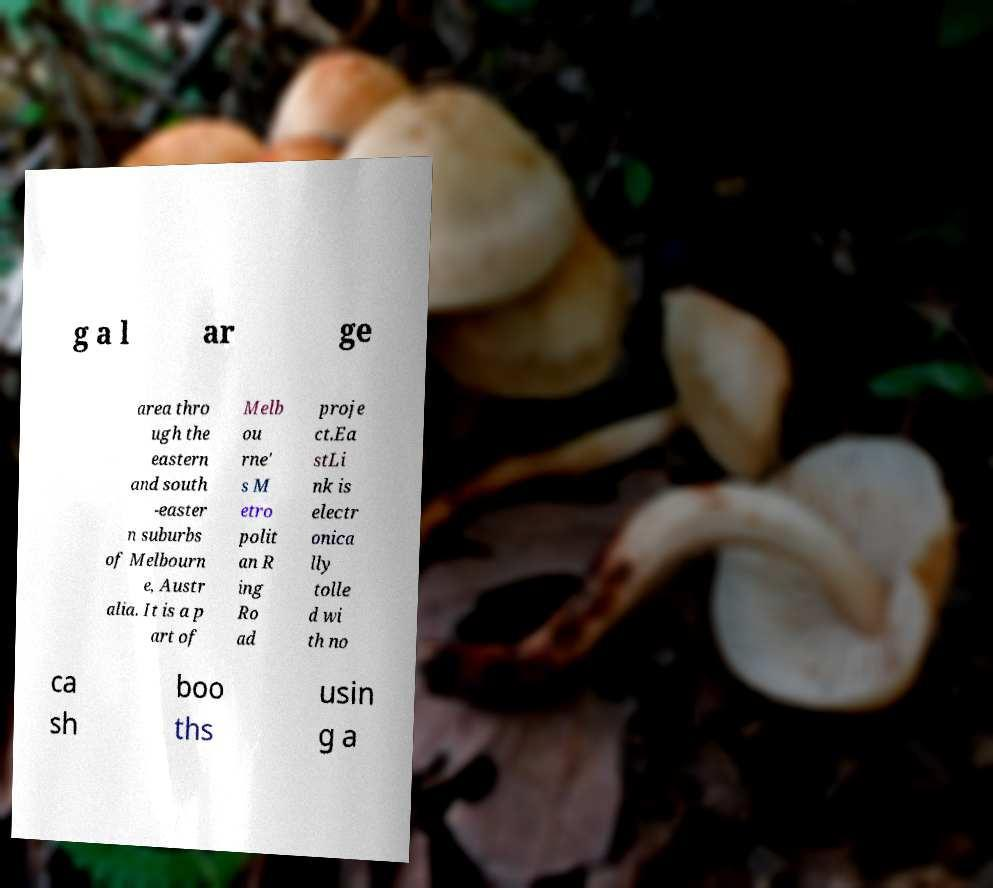Can you read and provide the text displayed in the image?This photo seems to have some interesting text. Can you extract and type it out for me? g a l ar ge area thro ugh the eastern and south -easter n suburbs of Melbourn e, Austr alia. It is a p art of Melb ou rne' s M etro polit an R ing Ro ad proje ct.Ea stLi nk is electr onica lly tolle d wi th no ca sh boo ths usin g a 